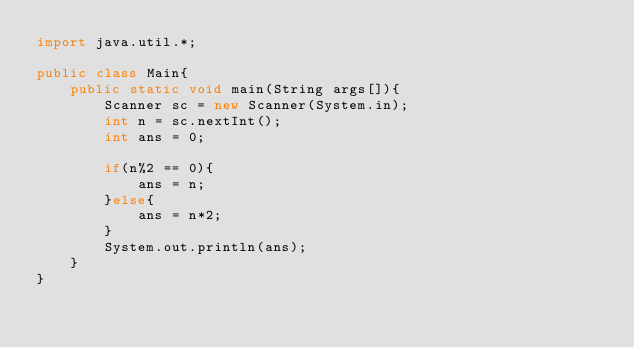<code> <loc_0><loc_0><loc_500><loc_500><_Java_>import java.util.*;

public class Main{
    public static void main(String args[]){
        Scanner sc = new Scanner(System.in);
        int n = sc.nextInt();
        int ans = 0;
        
        if(n%2 == 0){
            ans = n;
        }else{
            ans = n*2;
        }
        System.out.println(ans);
    }
}</code> 